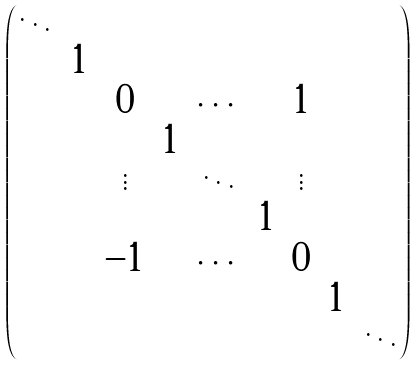Convert formula to latex. <formula><loc_0><loc_0><loc_500><loc_500>\begin{pmatrix} \ddots & & & & & & & & \\ & 1 & & & & & & & \\ & & 0 & & \cdots & & 1 & & \\ & & & 1 & & & & & \\ & & \vdots & & \ddots & & \vdots & & \\ & & & & & 1 & & & \\ & & - 1 & & \cdots & & 0 & & \\ & & & & & & & 1 & \\ & & & & & & & & \ddots \end{pmatrix}</formula> 